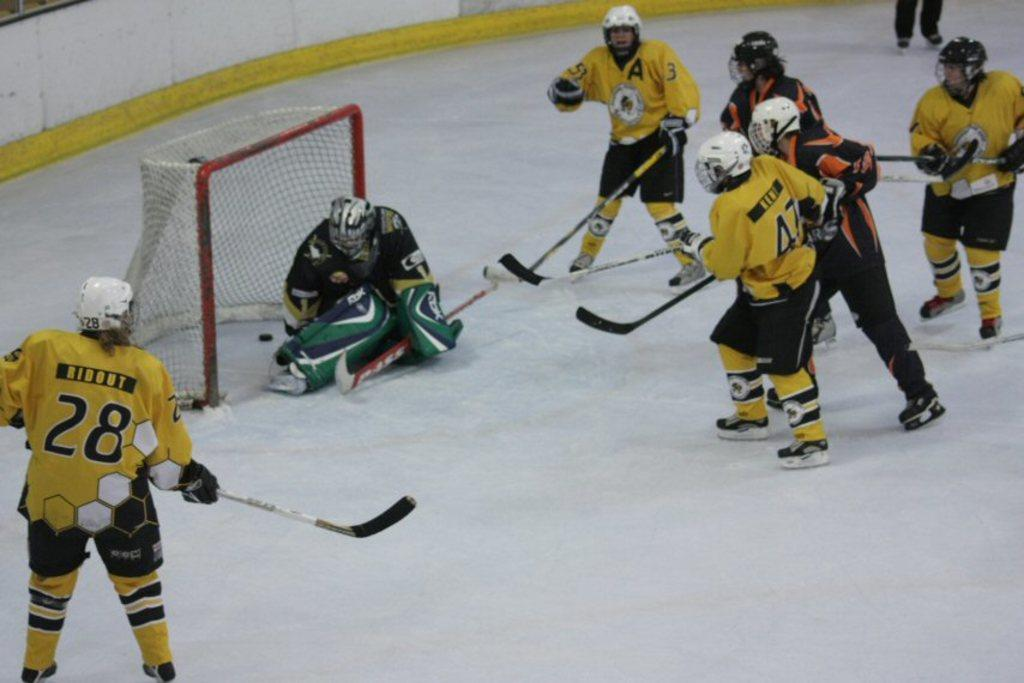What type of activity are the players in the image participating in? The players are engaged in a game. Can you identify any specific roles among the players? Yes, there is a goalkeeper in the image. How many players are involved in the game? The number of players cannot be determined from the provided facts. What type of skin condition is visible on the players in the image? There is no information about skin conditions in the image, as the focus is on the game and the players' roles. 